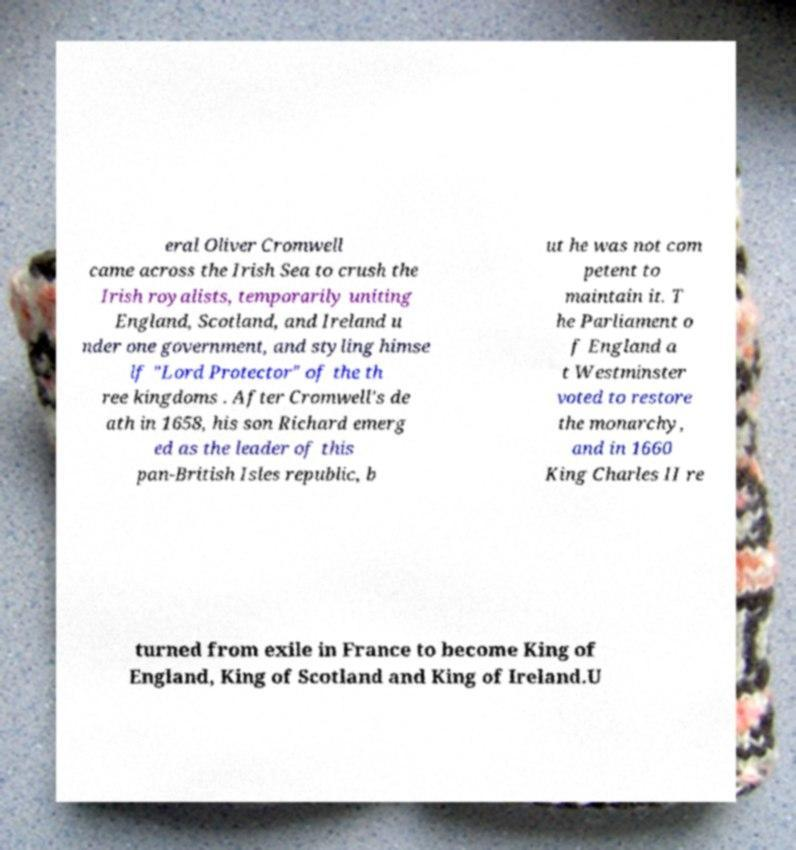There's text embedded in this image that I need extracted. Can you transcribe it verbatim? eral Oliver Cromwell came across the Irish Sea to crush the Irish royalists, temporarily uniting England, Scotland, and Ireland u nder one government, and styling himse lf "Lord Protector" of the th ree kingdoms . After Cromwell's de ath in 1658, his son Richard emerg ed as the leader of this pan-British Isles republic, b ut he was not com petent to maintain it. T he Parliament o f England a t Westminster voted to restore the monarchy, and in 1660 King Charles II re turned from exile in France to become King of England, King of Scotland and King of Ireland.U 